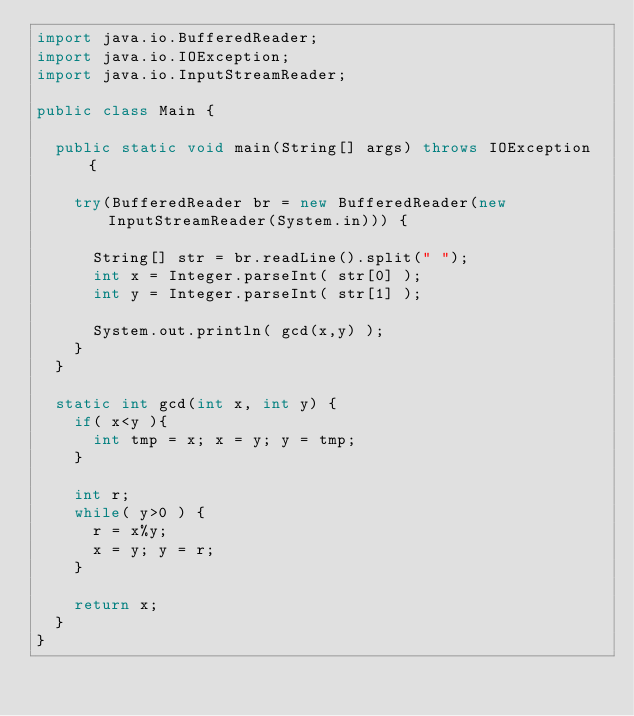Convert code to text. <code><loc_0><loc_0><loc_500><loc_500><_Java_>import java.io.BufferedReader;
import java.io.IOException;
import java.io.InputStreamReader;

public class Main {

  public static void main(String[] args) throws IOException {
    
    try(BufferedReader br = new BufferedReader(new InputStreamReader(System.in))) {

      String[] str = br.readLine().split(" ");
      int x = Integer.parseInt( str[0] );
      int y = Integer.parseInt( str[1] );

      System.out.println( gcd(x,y) );
    }
  }

  static int gcd(int x, int y) {
    if( x<y ){
      int tmp = x; x = y; y = tmp;
    }

    int r;
    while( y>0 ) {
      r = x%y;
      x = y; y = r;
    }

    return x;
  }
}
</code> 